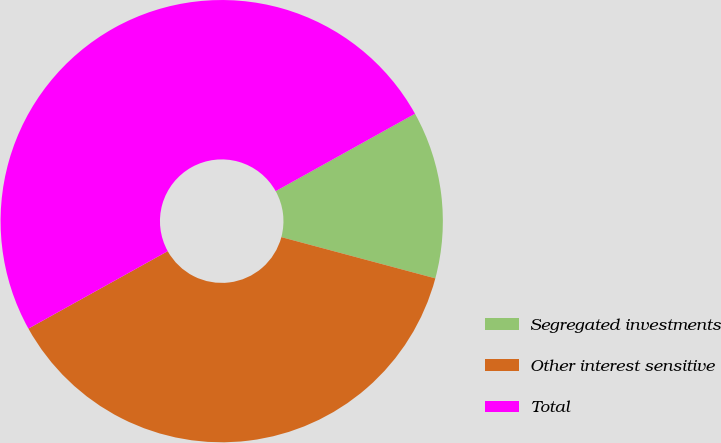<chart> <loc_0><loc_0><loc_500><loc_500><pie_chart><fcel>Segregated investments<fcel>Other interest sensitive<fcel>Total<nl><fcel>12.24%<fcel>37.76%<fcel>50.0%<nl></chart> 